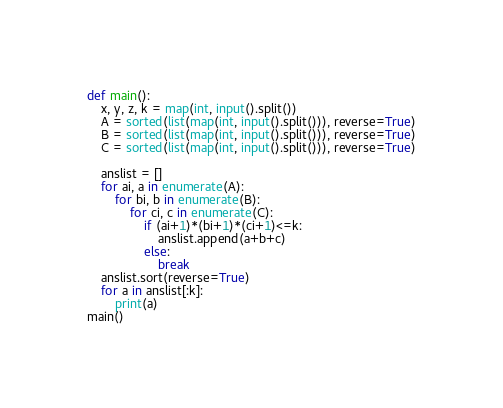<code> <loc_0><loc_0><loc_500><loc_500><_Python_>def main():
    x, y, z, k = map(int, input().split())
    A = sorted(list(map(int, input().split())), reverse=True)
    B = sorted(list(map(int, input().split())), reverse=True)
    C = sorted(list(map(int, input().split())), reverse=True)
    
    anslist = []
    for ai, a in enumerate(A):
        for bi, b in enumerate(B):
            for ci, c in enumerate(C):
                if (ai+1)*(bi+1)*(ci+1)<=k:
                    anslist.append(a+b+c)
                else:
                    break    
    anslist.sort(reverse=True)
    for a in anslist[:k]:
        print(a)
main()</code> 